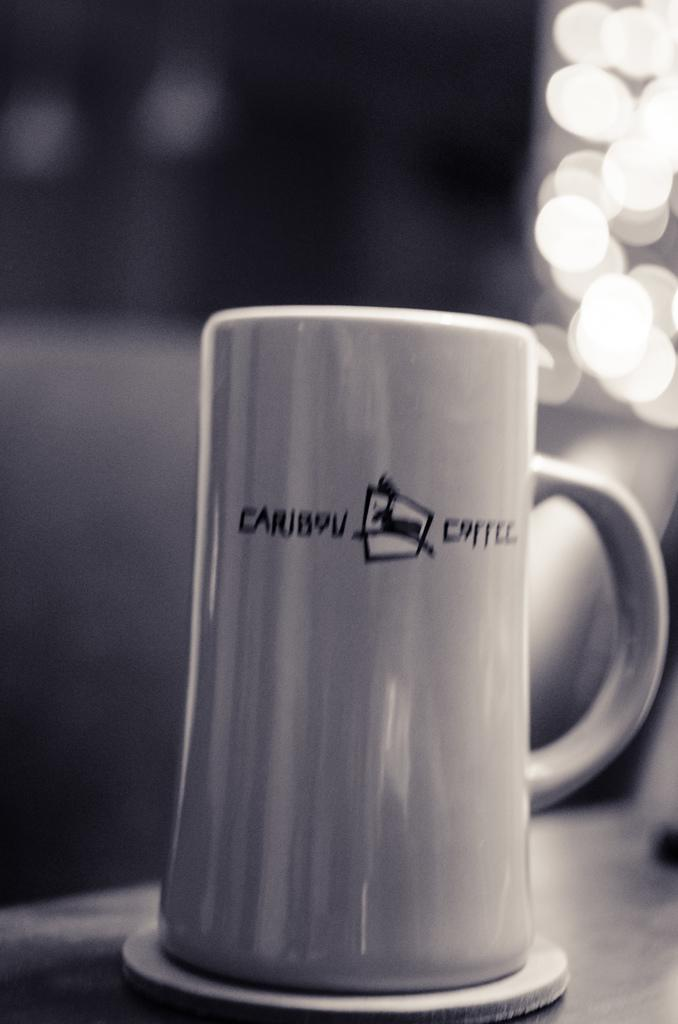Provide a one-sentence caption for the provided image. A Caribou Coffee brand mug sits on a coaster. 